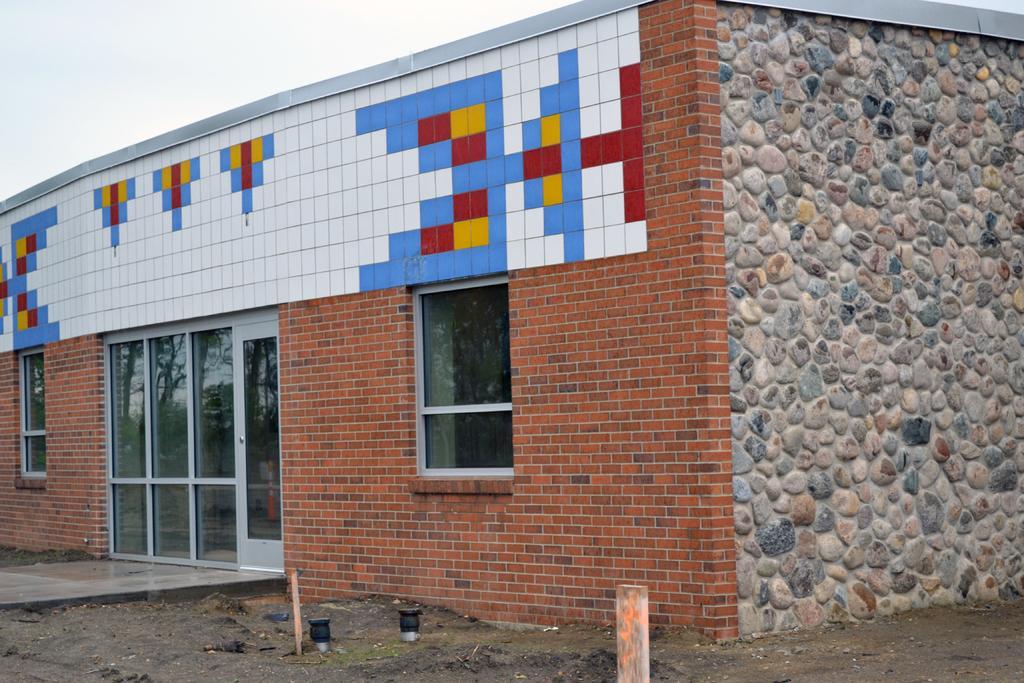In one or two sentences, can you explain what this image depicts? Here in this picture we can see a building present and on its front we can see a door and couple of windows present on it over there and on the ground we can see grass present over there. 